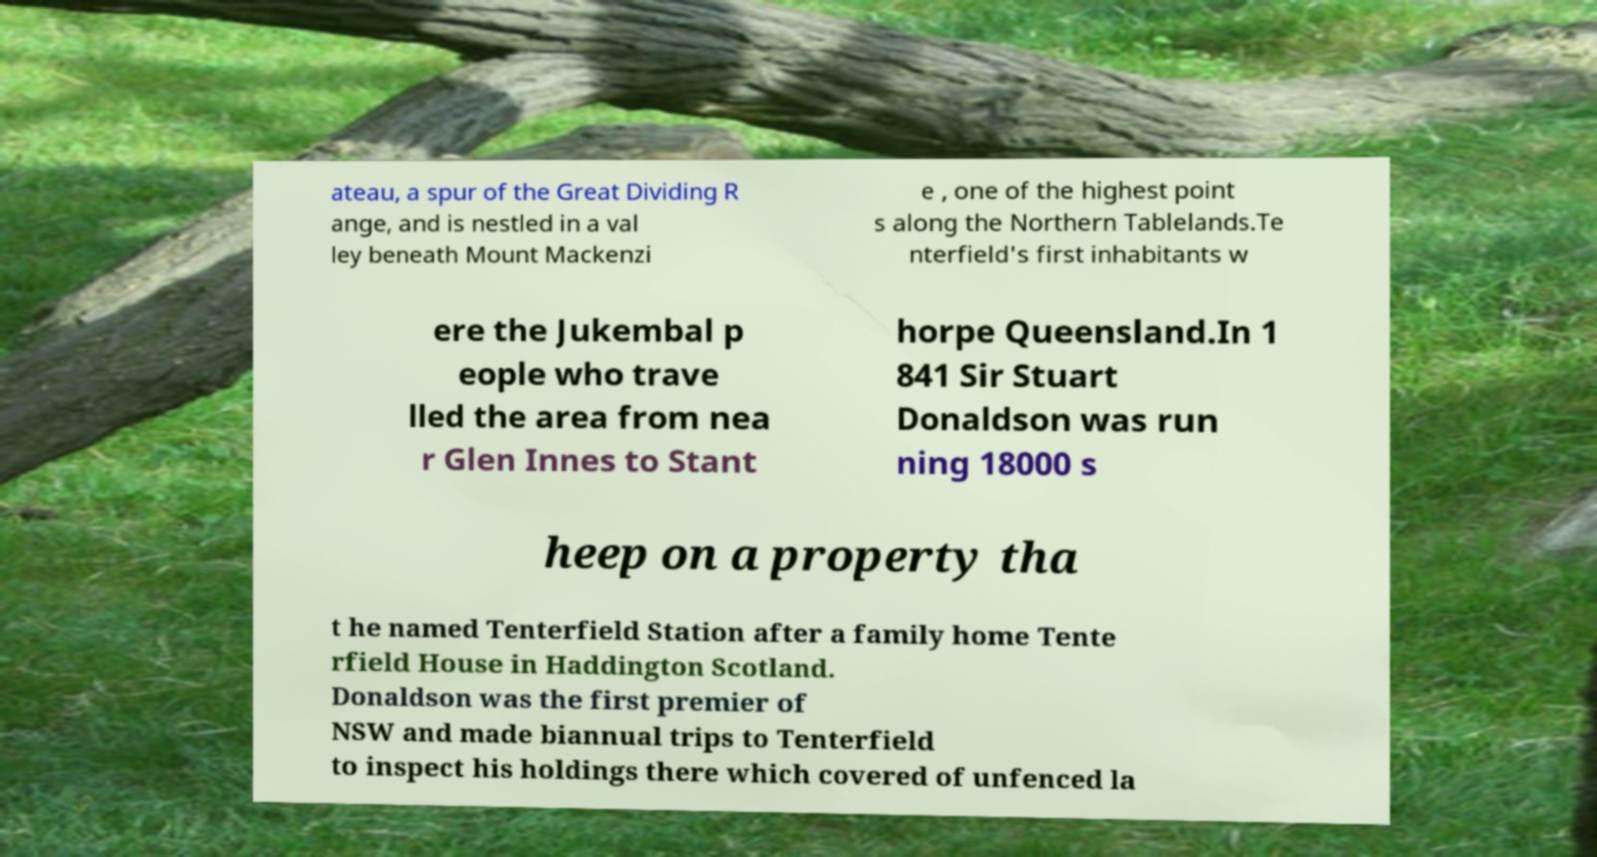Can you read and provide the text displayed in the image?This photo seems to have some interesting text. Can you extract and type it out for me? ateau, a spur of the Great Dividing R ange, and is nestled in a val ley beneath Mount Mackenzi e , one of the highest point s along the Northern Tablelands.Te nterfield's first inhabitants w ere the Jukembal p eople who trave lled the area from nea r Glen Innes to Stant horpe Queensland.In 1 841 Sir Stuart Donaldson was run ning 18000 s heep on a property tha t he named Tenterfield Station after a family home Tente rfield House in Haddington Scotland. Donaldson was the first premier of NSW and made biannual trips to Tenterfield to inspect his holdings there which covered of unfenced la 